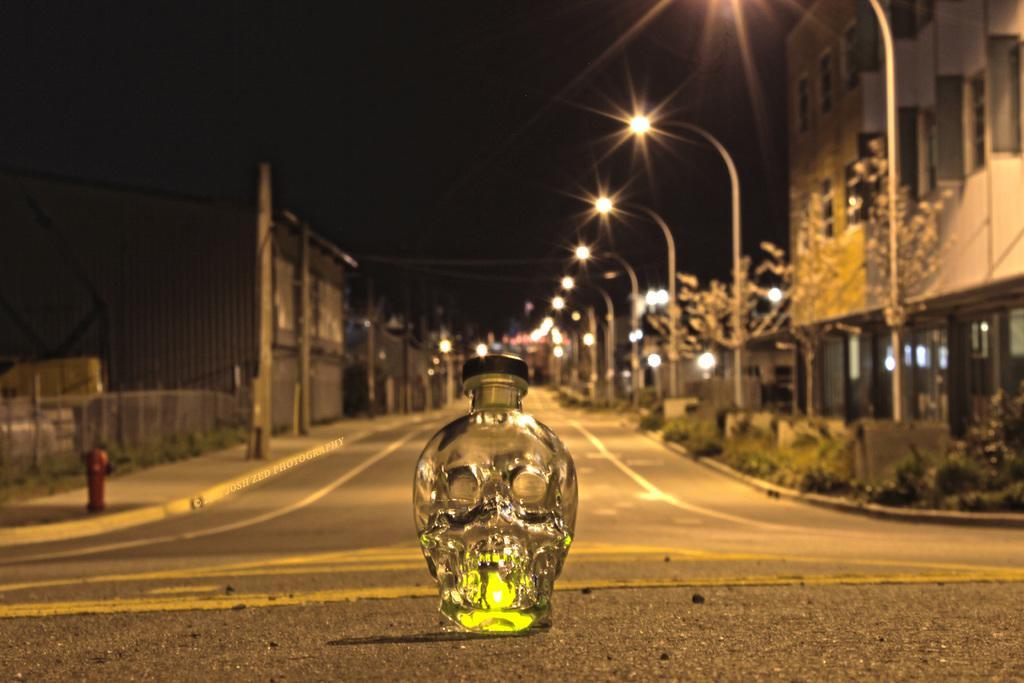How would you summarize this image in a sentence or two? This is the picture of a street where we have some buildings, poles and lights to it and there is a glass bottle in between the road which has a black color lid. 